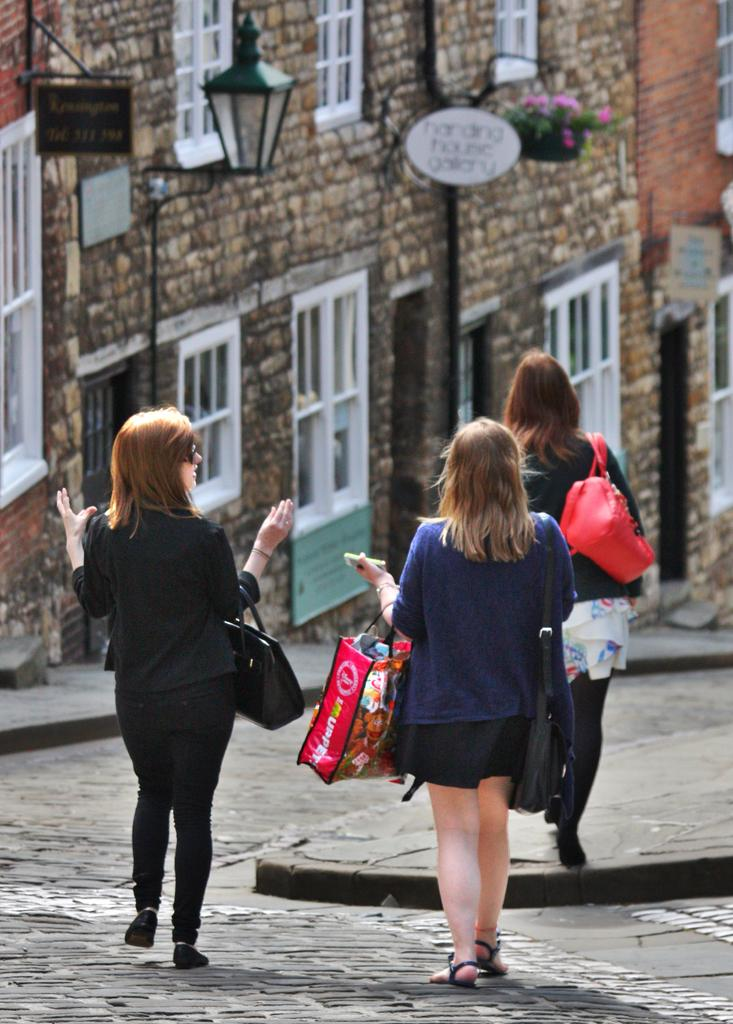How many women are in the foreground of the picture? There are three women in the foreground of the picture. What are the women holding in the picture? The women are holding bags. What are the women doing in the picture? The women are walking down the road. What can be seen in the background of the picture? There are buildings, a street light, boards, flower pots, and windows in the background of the picture. What type of camera can be seen in the hands of the women in the picture? There is no camera visible in the hands of the women in the picture. What kind of feast is being prepared in the background of the picture? There is no feast or any indication of food preparation in the background of the picture. 